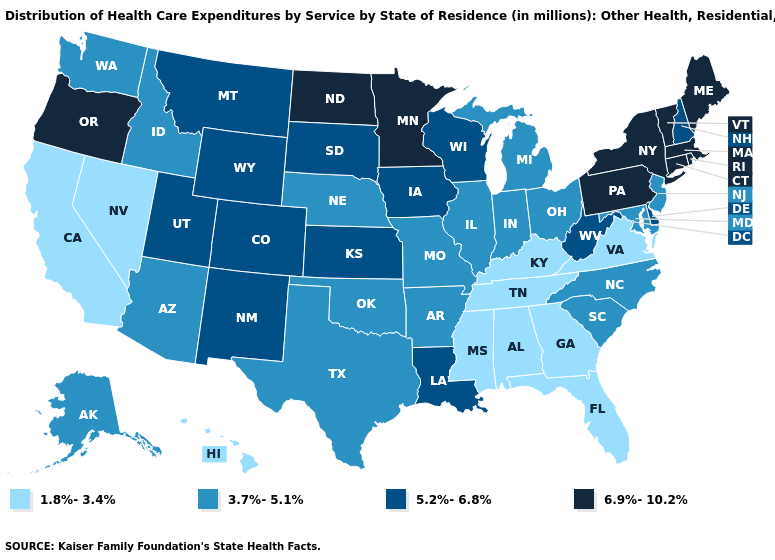Does Missouri have the highest value in the MidWest?
Concise answer only. No. Name the states that have a value in the range 5.2%-6.8%?
Quick response, please. Colorado, Delaware, Iowa, Kansas, Louisiana, Montana, New Hampshire, New Mexico, South Dakota, Utah, West Virginia, Wisconsin, Wyoming. Name the states that have a value in the range 3.7%-5.1%?
Keep it brief. Alaska, Arizona, Arkansas, Idaho, Illinois, Indiana, Maryland, Michigan, Missouri, Nebraska, New Jersey, North Carolina, Ohio, Oklahoma, South Carolina, Texas, Washington. Does Montana have a lower value than Oregon?
Quick response, please. Yes. Which states have the highest value in the USA?
Concise answer only. Connecticut, Maine, Massachusetts, Minnesota, New York, North Dakota, Oregon, Pennsylvania, Rhode Island, Vermont. Which states have the highest value in the USA?
Give a very brief answer. Connecticut, Maine, Massachusetts, Minnesota, New York, North Dakota, Oregon, Pennsylvania, Rhode Island, Vermont. Does South Carolina have the highest value in the USA?
Concise answer only. No. What is the value of Ohio?
Give a very brief answer. 3.7%-5.1%. Does the first symbol in the legend represent the smallest category?
Give a very brief answer. Yes. Does the first symbol in the legend represent the smallest category?
Be succinct. Yes. What is the value of Massachusetts?
Be succinct. 6.9%-10.2%. Among the states that border Iowa , does Illinois have the lowest value?
Keep it brief. Yes. Name the states that have a value in the range 1.8%-3.4%?
Answer briefly. Alabama, California, Florida, Georgia, Hawaii, Kentucky, Mississippi, Nevada, Tennessee, Virginia. Does Kentucky have a lower value than Alabama?
Answer briefly. No. What is the lowest value in states that border New Mexico?
Be succinct. 3.7%-5.1%. 